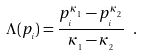Convert formula to latex. <formula><loc_0><loc_0><loc_500><loc_500>\Lambda ( p _ { _ { i } } ) = \frac { p _ { _ { i } } ^ { \kappa _ { _ { 1 } } } - p _ { _ { i } } ^ { \kappa _ { _ { 2 } } } } { \kappa _ { _ { 1 } } - \kappa _ { _ { 2 } } } \ .</formula> 